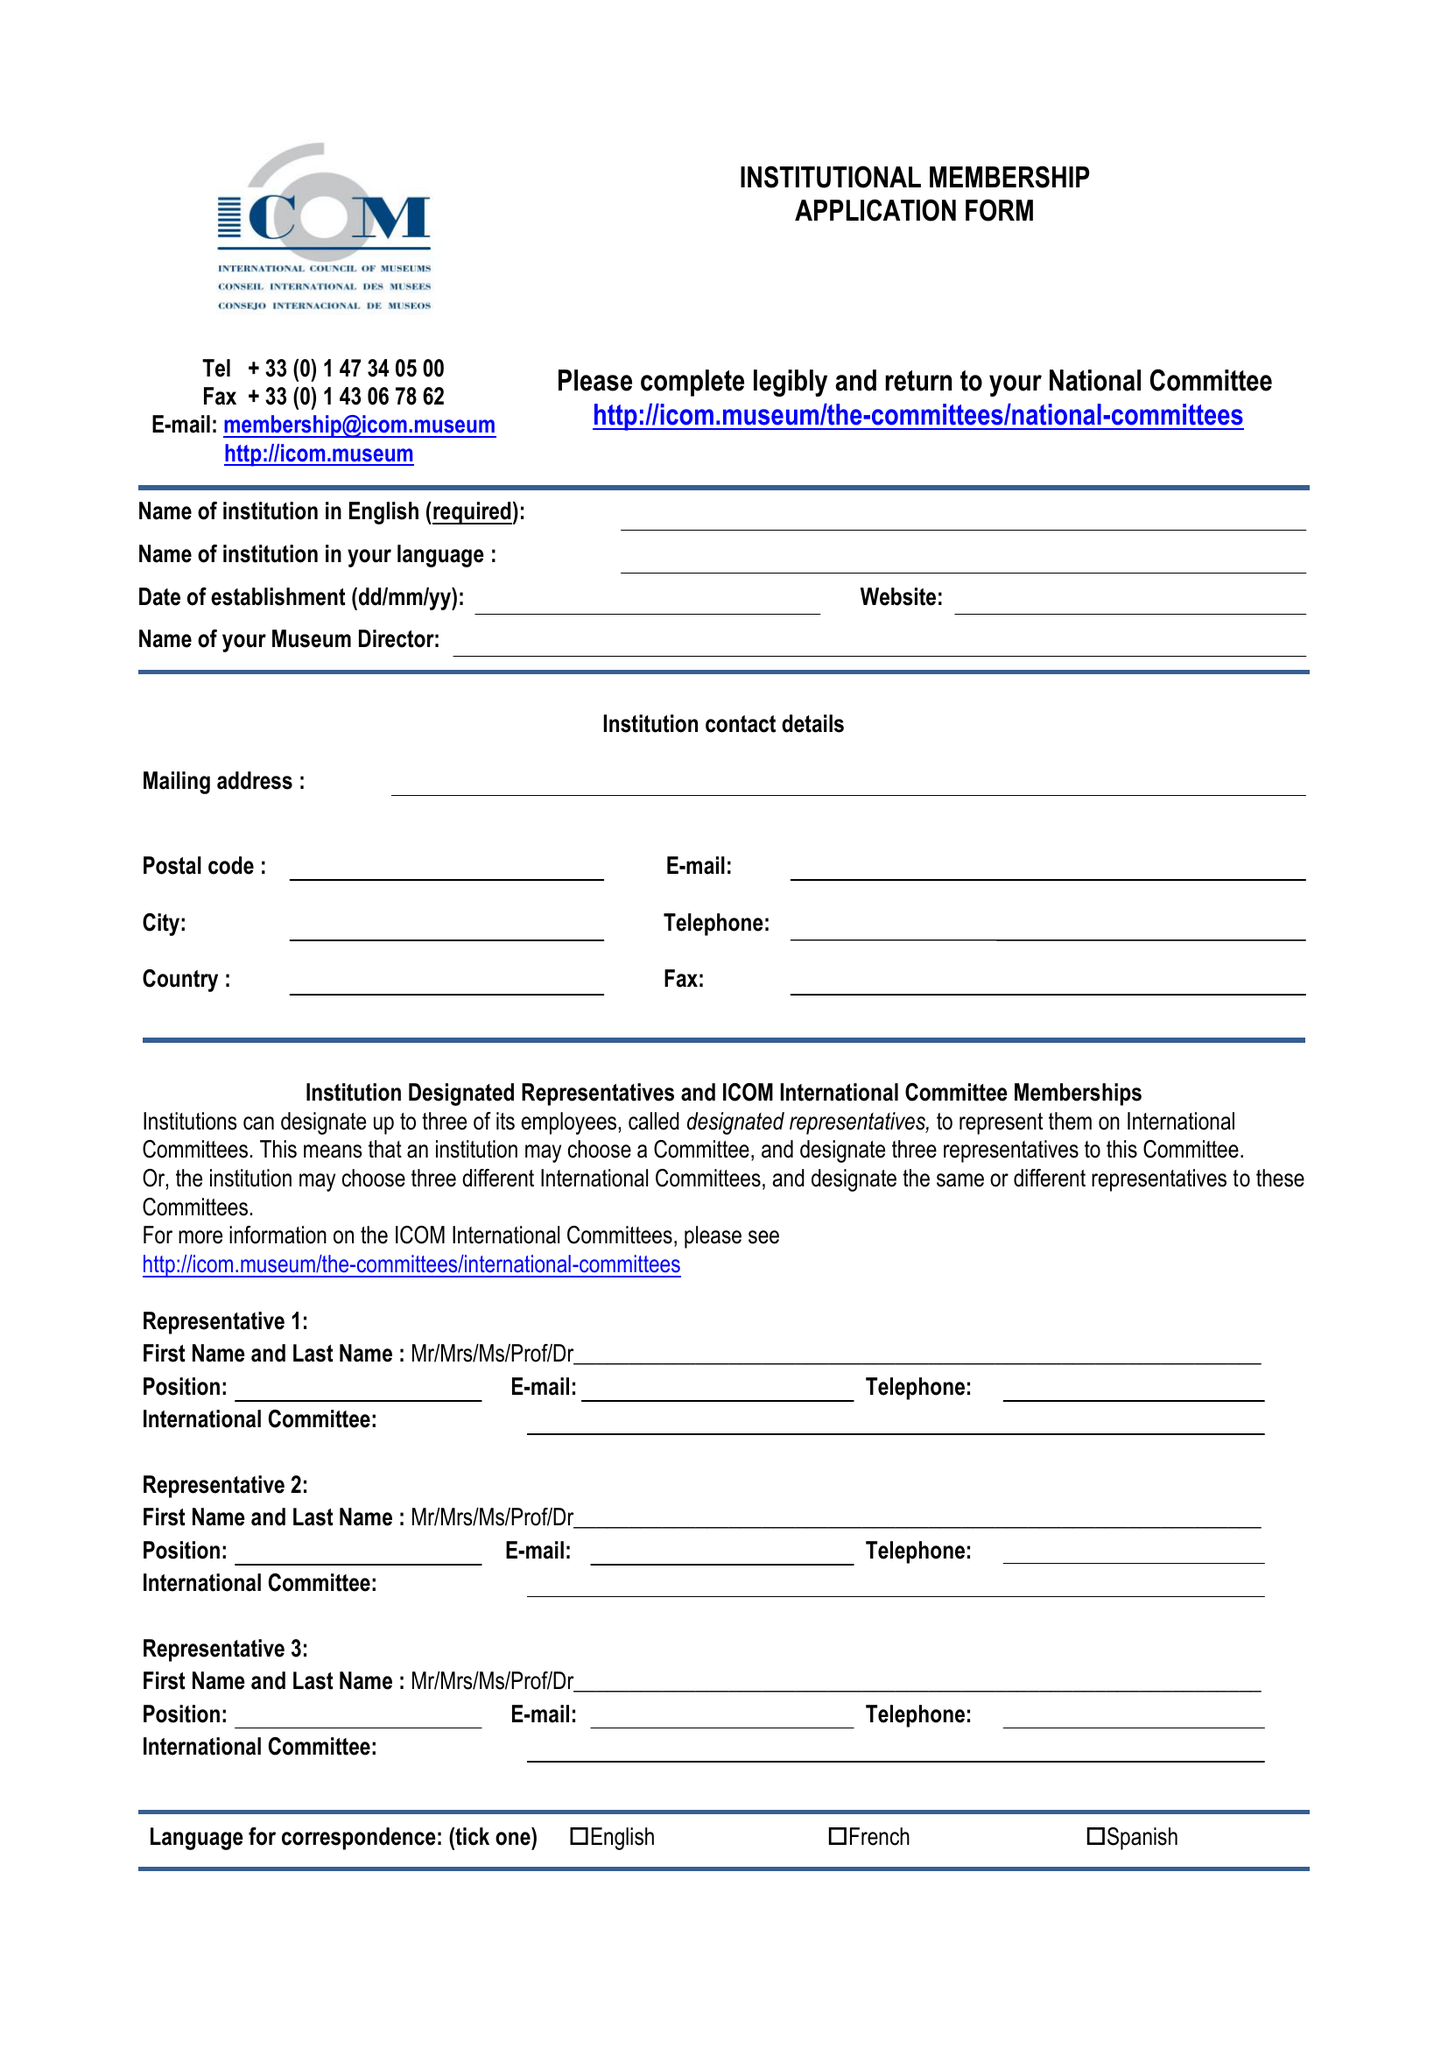What is the value for the spending_annually_in_british_pounds?
Answer the question using a single word or phrase. 131621.00 